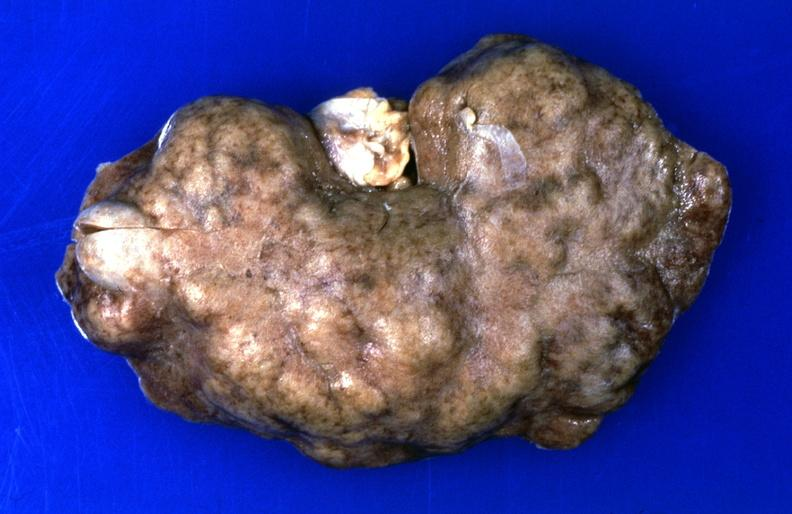where is this?
Answer the question using a single word or phrase. Urinary 